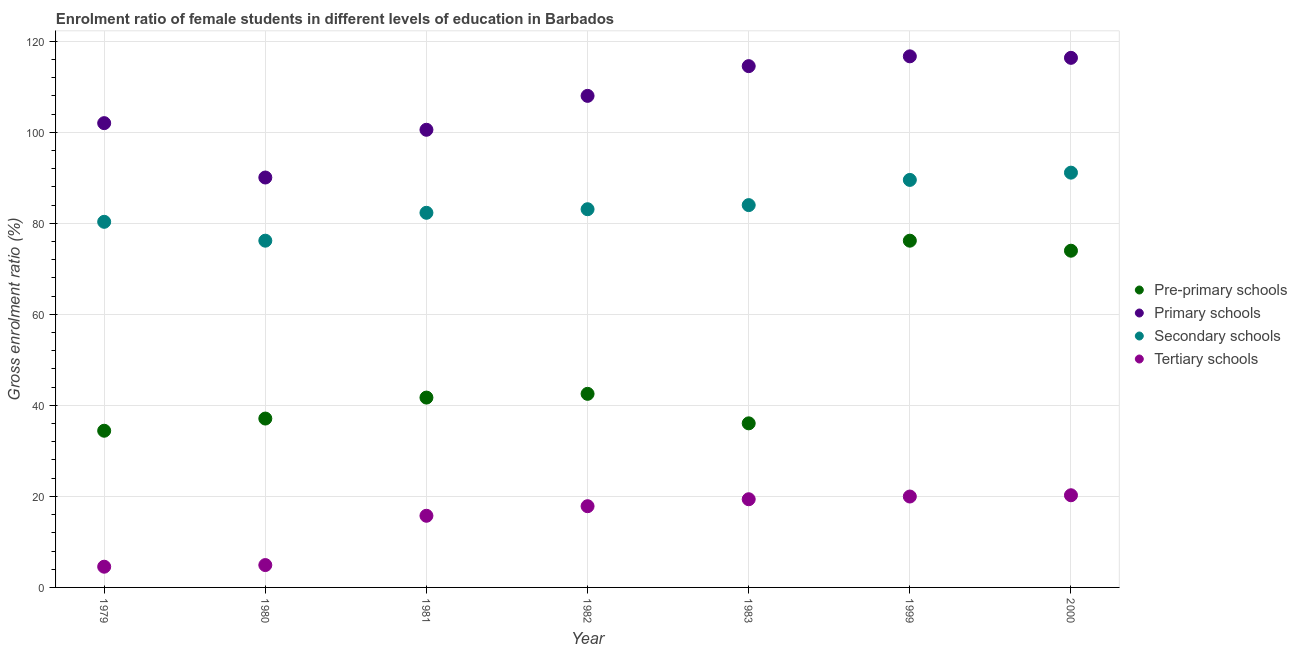How many different coloured dotlines are there?
Your response must be concise. 4. What is the gross enrolment ratio(male) in tertiary schools in 1999?
Give a very brief answer. 19.97. Across all years, what is the maximum gross enrolment ratio(male) in primary schools?
Your answer should be compact. 116.68. Across all years, what is the minimum gross enrolment ratio(male) in pre-primary schools?
Give a very brief answer. 34.42. In which year was the gross enrolment ratio(male) in secondary schools maximum?
Provide a short and direct response. 2000. In which year was the gross enrolment ratio(male) in pre-primary schools minimum?
Your answer should be compact. 1979. What is the total gross enrolment ratio(male) in primary schools in the graph?
Keep it short and to the point. 748.15. What is the difference between the gross enrolment ratio(male) in pre-primary schools in 1980 and that in 1981?
Provide a succinct answer. -4.61. What is the difference between the gross enrolment ratio(male) in secondary schools in 1982 and the gross enrolment ratio(male) in tertiary schools in 1981?
Your answer should be compact. 67.35. What is the average gross enrolment ratio(male) in pre-primary schools per year?
Give a very brief answer. 48.85. In the year 1980, what is the difference between the gross enrolment ratio(male) in pre-primary schools and gross enrolment ratio(male) in secondary schools?
Provide a short and direct response. -39.08. In how many years, is the gross enrolment ratio(male) in tertiary schools greater than 96 %?
Offer a terse response. 0. What is the ratio of the gross enrolment ratio(male) in primary schools in 1979 to that in 1999?
Keep it short and to the point. 0.87. What is the difference between the highest and the second highest gross enrolment ratio(male) in tertiary schools?
Offer a very short reply. 0.28. What is the difference between the highest and the lowest gross enrolment ratio(male) in primary schools?
Your response must be concise. 26.62. In how many years, is the gross enrolment ratio(male) in secondary schools greater than the average gross enrolment ratio(male) in secondary schools taken over all years?
Offer a terse response. 3. Is the sum of the gross enrolment ratio(male) in pre-primary schools in 1981 and 1982 greater than the maximum gross enrolment ratio(male) in tertiary schools across all years?
Make the answer very short. Yes. Is it the case that in every year, the sum of the gross enrolment ratio(male) in pre-primary schools and gross enrolment ratio(male) in primary schools is greater than the gross enrolment ratio(male) in secondary schools?
Keep it short and to the point. Yes. What is the title of the graph?
Give a very brief answer. Enrolment ratio of female students in different levels of education in Barbados. Does "Negligence towards children" appear as one of the legend labels in the graph?
Make the answer very short. No. What is the label or title of the Y-axis?
Provide a short and direct response. Gross enrolment ratio (%). What is the Gross enrolment ratio (%) of Pre-primary schools in 1979?
Offer a very short reply. 34.42. What is the Gross enrolment ratio (%) in Primary schools in 1979?
Provide a succinct answer. 102. What is the Gross enrolment ratio (%) of Secondary schools in 1979?
Provide a short and direct response. 80.32. What is the Gross enrolment ratio (%) in Tertiary schools in 1979?
Keep it short and to the point. 4.55. What is the Gross enrolment ratio (%) of Pre-primary schools in 1980?
Your answer should be compact. 37.1. What is the Gross enrolment ratio (%) in Primary schools in 1980?
Your answer should be very brief. 90.06. What is the Gross enrolment ratio (%) in Secondary schools in 1980?
Keep it short and to the point. 76.18. What is the Gross enrolment ratio (%) of Tertiary schools in 1980?
Your answer should be compact. 4.91. What is the Gross enrolment ratio (%) of Pre-primary schools in 1981?
Make the answer very short. 41.71. What is the Gross enrolment ratio (%) of Primary schools in 1981?
Give a very brief answer. 100.54. What is the Gross enrolment ratio (%) of Secondary schools in 1981?
Your response must be concise. 82.31. What is the Gross enrolment ratio (%) of Tertiary schools in 1981?
Provide a succinct answer. 15.74. What is the Gross enrolment ratio (%) in Pre-primary schools in 1982?
Give a very brief answer. 42.53. What is the Gross enrolment ratio (%) of Primary schools in 1982?
Provide a succinct answer. 107.99. What is the Gross enrolment ratio (%) of Secondary schools in 1982?
Offer a terse response. 83.09. What is the Gross enrolment ratio (%) of Tertiary schools in 1982?
Make the answer very short. 17.85. What is the Gross enrolment ratio (%) of Pre-primary schools in 1983?
Offer a very short reply. 36.05. What is the Gross enrolment ratio (%) of Primary schools in 1983?
Your answer should be compact. 114.53. What is the Gross enrolment ratio (%) of Secondary schools in 1983?
Provide a short and direct response. 84. What is the Gross enrolment ratio (%) in Tertiary schools in 1983?
Provide a short and direct response. 19.37. What is the Gross enrolment ratio (%) of Pre-primary schools in 1999?
Make the answer very short. 76.18. What is the Gross enrolment ratio (%) of Primary schools in 1999?
Your answer should be compact. 116.68. What is the Gross enrolment ratio (%) in Secondary schools in 1999?
Your response must be concise. 89.53. What is the Gross enrolment ratio (%) in Tertiary schools in 1999?
Offer a very short reply. 19.97. What is the Gross enrolment ratio (%) in Pre-primary schools in 2000?
Your answer should be very brief. 73.98. What is the Gross enrolment ratio (%) of Primary schools in 2000?
Your answer should be compact. 116.35. What is the Gross enrolment ratio (%) of Secondary schools in 2000?
Make the answer very short. 91.12. What is the Gross enrolment ratio (%) of Tertiary schools in 2000?
Keep it short and to the point. 20.25. Across all years, what is the maximum Gross enrolment ratio (%) in Pre-primary schools?
Your answer should be very brief. 76.18. Across all years, what is the maximum Gross enrolment ratio (%) of Primary schools?
Your response must be concise. 116.68. Across all years, what is the maximum Gross enrolment ratio (%) of Secondary schools?
Offer a very short reply. 91.12. Across all years, what is the maximum Gross enrolment ratio (%) of Tertiary schools?
Keep it short and to the point. 20.25. Across all years, what is the minimum Gross enrolment ratio (%) in Pre-primary schools?
Your answer should be very brief. 34.42. Across all years, what is the minimum Gross enrolment ratio (%) in Primary schools?
Your answer should be compact. 90.06. Across all years, what is the minimum Gross enrolment ratio (%) in Secondary schools?
Your response must be concise. 76.18. Across all years, what is the minimum Gross enrolment ratio (%) in Tertiary schools?
Keep it short and to the point. 4.55. What is the total Gross enrolment ratio (%) in Pre-primary schools in the graph?
Ensure brevity in your answer.  341.97. What is the total Gross enrolment ratio (%) in Primary schools in the graph?
Make the answer very short. 748.15. What is the total Gross enrolment ratio (%) in Secondary schools in the graph?
Make the answer very short. 586.55. What is the total Gross enrolment ratio (%) in Tertiary schools in the graph?
Ensure brevity in your answer.  102.65. What is the difference between the Gross enrolment ratio (%) of Pre-primary schools in 1979 and that in 1980?
Provide a short and direct response. -2.68. What is the difference between the Gross enrolment ratio (%) of Primary schools in 1979 and that in 1980?
Provide a short and direct response. 11.94. What is the difference between the Gross enrolment ratio (%) of Secondary schools in 1979 and that in 1980?
Your answer should be very brief. 4.15. What is the difference between the Gross enrolment ratio (%) in Tertiary schools in 1979 and that in 1980?
Provide a succinct answer. -0.36. What is the difference between the Gross enrolment ratio (%) of Pre-primary schools in 1979 and that in 1981?
Your answer should be compact. -7.29. What is the difference between the Gross enrolment ratio (%) in Primary schools in 1979 and that in 1981?
Your response must be concise. 1.46. What is the difference between the Gross enrolment ratio (%) of Secondary schools in 1979 and that in 1981?
Provide a short and direct response. -1.98. What is the difference between the Gross enrolment ratio (%) of Tertiary schools in 1979 and that in 1981?
Keep it short and to the point. -11.19. What is the difference between the Gross enrolment ratio (%) of Pre-primary schools in 1979 and that in 1982?
Give a very brief answer. -8.11. What is the difference between the Gross enrolment ratio (%) in Primary schools in 1979 and that in 1982?
Your response must be concise. -5.99. What is the difference between the Gross enrolment ratio (%) of Secondary schools in 1979 and that in 1982?
Make the answer very short. -2.77. What is the difference between the Gross enrolment ratio (%) of Tertiary schools in 1979 and that in 1982?
Offer a terse response. -13.29. What is the difference between the Gross enrolment ratio (%) in Pre-primary schools in 1979 and that in 1983?
Your answer should be compact. -1.63. What is the difference between the Gross enrolment ratio (%) in Primary schools in 1979 and that in 1983?
Your response must be concise. -12.52. What is the difference between the Gross enrolment ratio (%) of Secondary schools in 1979 and that in 1983?
Give a very brief answer. -3.67. What is the difference between the Gross enrolment ratio (%) in Tertiary schools in 1979 and that in 1983?
Your answer should be compact. -14.82. What is the difference between the Gross enrolment ratio (%) in Pre-primary schools in 1979 and that in 1999?
Your response must be concise. -41.75. What is the difference between the Gross enrolment ratio (%) in Primary schools in 1979 and that in 1999?
Give a very brief answer. -14.68. What is the difference between the Gross enrolment ratio (%) of Secondary schools in 1979 and that in 1999?
Your answer should be very brief. -9.21. What is the difference between the Gross enrolment ratio (%) in Tertiary schools in 1979 and that in 1999?
Your response must be concise. -15.42. What is the difference between the Gross enrolment ratio (%) in Pre-primary schools in 1979 and that in 2000?
Keep it short and to the point. -39.55. What is the difference between the Gross enrolment ratio (%) of Primary schools in 1979 and that in 2000?
Offer a terse response. -14.35. What is the difference between the Gross enrolment ratio (%) in Secondary schools in 1979 and that in 2000?
Offer a very short reply. -10.8. What is the difference between the Gross enrolment ratio (%) of Tertiary schools in 1979 and that in 2000?
Your answer should be compact. -15.7. What is the difference between the Gross enrolment ratio (%) in Pre-primary schools in 1980 and that in 1981?
Your response must be concise. -4.61. What is the difference between the Gross enrolment ratio (%) of Primary schools in 1980 and that in 1981?
Provide a short and direct response. -10.49. What is the difference between the Gross enrolment ratio (%) in Secondary schools in 1980 and that in 1981?
Offer a terse response. -6.13. What is the difference between the Gross enrolment ratio (%) of Tertiary schools in 1980 and that in 1981?
Provide a short and direct response. -10.83. What is the difference between the Gross enrolment ratio (%) in Pre-primary schools in 1980 and that in 1982?
Your answer should be compact. -5.43. What is the difference between the Gross enrolment ratio (%) in Primary schools in 1980 and that in 1982?
Offer a very short reply. -17.94. What is the difference between the Gross enrolment ratio (%) in Secondary schools in 1980 and that in 1982?
Your answer should be very brief. -6.91. What is the difference between the Gross enrolment ratio (%) of Tertiary schools in 1980 and that in 1982?
Provide a succinct answer. -12.93. What is the difference between the Gross enrolment ratio (%) in Pre-primary schools in 1980 and that in 1983?
Offer a very short reply. 1.05. What is the difference between the Gross enrolment ratio (%) in Primary schools in 1980 and that in 1983?
Your response must be concise. -24.47. What is the difference between the Gross enrolment ratio (%) in Secondary schools in 1980 and that in 1983?
Give a very brief answer. -7.82. What is the difference between the Gross enrolment ratio (%) in Tertiary schools in 1980 and that in 1983?
Your answer should be compact. -14.46. What is the difference between the Gross enrolment ratio (%) of Pre-primary schools in 1980 and that in 1999?
Make the answer very short. -39.08. What is the difference between the Gross enrolment ratio (%) in Primary schools in 1980 and that in 1999?
Provide a short and direct response. -26.62. What is the difference between the Gross enrolment ratio (%) in Secondary schools in 1980 and that in 1999?
Offer a terse response. -13.35. What is the difference between the Gross enrolment ratio (%) in Tertiary schools in 1980 and that in 1999?
Your answer should be very brief. -15.06. What is the difference between the Gross enrolment ratio (%) in Pre-primary schools in 1980 and that in 2000?
Offer a terse response. -36.87. What is the difference between the Gross enrolment ratio (%) in Primary schools in 1980 and that in 2000?
Offer a very short reply. -26.29. What is the difference between the Gross enrolment ratio (%) of Secondary schools in 1980 and that in 2000?
Offer a very short reply. -14.95. What is the difference between the Gross enrolment ratio (%) in Tertiary schools in 1980 and that in 2000?
Your answer should be very brief. -15.34. What is the difference between the Gross enrolment ratio (%) of Pre-primary schools in 1981 and that in 1982?
Give a very brief answer. -0.82. What is the difference between the Gross enrolment ratio (%) in Primary schools in 1981 and that in 1982?
Your answer should be very brief. -7.45. What is the difference between the Gross enrolment ratio (%) in Secondary schools in 1981 and that in 1982?
Keep it short and to the point. -0.78. What is the difference between the Gross enrolment ratio (%) in Tertiary schools in 1981 and that in 1982?
Give a very brief answer. -2.1. What is the difference between the Gross enrolment ratio (%) in Pre-primary schools in 1981 and that in 1983?
Your response must be concise. 5.66. What is the difference between the Gross enrolment ratio (%) in Primary schools in 1981 and that in 1983?
Offer a terse response. -13.98. What is the difference between the Gross enrolment ratio (%) in Secondary schools in 1981 and that in 1983?
Keep it short and to the point. -1.69. What is the difference between the Gross enrolment ratio (%) in Tertiary schools in 1981 and that in 1983?
Make the answer very short. -3.63. What is the difference between the Gross enrolment ratio (%) in Pre-primary schools in 1981 and that in 1999?
Your response must be concise. -34.47. What is the difference between the Gross enrolment ratio (%) of Primary schools in 1981 and that in 1999?
Offer a terse response. -16.13. What is the difference between the Gross enrolment ratio (%) in Secondary schools in 1981 and that in 1999?
Offer a very short reply. -7.22. What is the difference between the Gross enrolment ratio (%) in Tertiary schools in 1981 and that in 1999?
Make the answer very short. -4.23. What is the difference between the Gross enrolment ratio (%) in Pre-primary schools in 1981 and that in 2000?
Offer a very short reply. -32.27. What is the difference between the Gross enrolment ratio (%) of Primary schools in 1981 and that in 2000?
Keep it short and to the point. -15.81. What is the difference between the Gross enrolment ratio (%) in Secondary schools in 1981 and that in 2000?
Provide a short and direct response. -8.82. What is the difference between the Gross enrolment ratio (%) in Tertiary schools in 1981 and that in 2000?
Give a very brief answer. -4.51. What is the difference between the Gross enrolment ratio (%) of Pre-primary schools in 1982 and that in 1983?
Provide a succinct answer. 6.48. What is the difference between the Gross enrolment ratio (%) in Primary schools in 1982 and that in 1983?
Keep it short and to the point. -6.53. What is the difference between the Gross enrolment ratio (%) in Secondary schools in 1982 and that in 1983?
Offer a terse response. -0.9. What is the difference between the Gross enrolment ratio (%) in Tertiary schools in 1982 and that in 1983?
Make the answer very short. -1.53. What is the difference between the Gross enrolment ratio (%) of Pre-primary schools in 1982 and that in 1999?
Provide a short and direct response. -33.65. What is the difference between the Gross enrolment ratio (%) in Primary schools in 1982 and that in 1999?
Give a very brief answer. -8.68. What is the difference between the Gross enrolment ratio (%) of Secondary schools in 1982 and that in 1999?
Give a very brief answer. -6.44. What is the difference between the Gross enrolment ratio (%) in Tertiary schools in 1982 and that in 1999?
Make the answer very short. -2.13. What is the difference between the Gross enrolment ratio (%) of Pre-primary schools in 1982 and that in 2000?
Your response must be concise. -31.44. What is the difference between the Gross enrolment ratio (%) of Primary schools in 1982 and that in 2000?
Your answer should be very brief. -8.36. What is the difference between the Gross enrolment ratio (%) in Secondary schools in 1982 and that in 2000?
Give a very brief answer. -8.03. What is the difference between the Gross enrolment ratio (%) in Tertiary schools in 1982 and that in 2000?
Your response must be concise. -2.4. What is the difference between the Gross enrolment ratio (%) in Pre-primary schools in 1983 and that in 1999?
Your answer should be very brief. -40.13. What is the difference between the Gross enrolment ratio (%) of Primary schools in 1983 and that in 1999?
Keep it short and to the point. -2.15. What is the difference between the Gross enrolment ratio (%) in Secondary schools in 1983 and that in 1999?
Provide a succinct answer. -5.53. What is the difference between the Gross enrolment ratio (%) in Tertiary schools in 1983 and that in 1999?
Your answer should be very brief. -0.6. What is the difference between the Gross enrolment ratio (%) in Pre-primary schools in 1983 and that in 2000?
Provide a succinct answer. -37.93. What is the difference between the Gross enrolment ratio (%) of Primary schools in 1983 and that in 2000?
Keep it short and to the point. -1.82. What is the difference between the Gross enrolment ratio (%) in Secondary schools in 1983 and that in 2000?
Provide a succinct answer. -7.13. What is the difference between the Gross enrolment ratio (%) in Tertiary schools in 1983 and that in 2000?
Your answer should be very brief. -0.88. What is the difference between the Gross enrolment ratio (%) of Pre-primary schools in 1999 and that in 2000?
Your answer should be very brief. 2.2. What is the difference between the Gross enrolment ratio (%) in Primary schools in 1999 and that in 2000?
Provide a succinct answer. 0.33. What is the difference between the Gross enrolment ratio (%) in Secondary schools in 1999 and that in 2000?
Your response must be concise. -1.59. What is the difference between the Gross enrolment ratio (%) of Tertiary schools in 1999 and that in 2000?
Give a very brief answer. -0.28. What is the difference between the Gross enrolment ratio (%) in Pre-primary schools in 1979 and the Gross enrolment ratio (%) in Primary schools in 1980?
Make the answer very short. -55.64. What is the difference between the Gross enrolment ratio (%) of Pre-primary schools in 1979 and the Gross enrolment ratio (%) of Secondary schools in 1980?
Provide a short and direct response. -41.75. What is the difference between the Gross enrolment ratio (%) in Pre-primary schools in 1979 and the Gross enrolment ratio (%) in Tertiary schools in 1980?
Make the answer very short. 29.51. What is the difference between the Gross enrolment ratio (%) in Primary schools in 1979 and the Gross enrolment ratio (%) in Secondary schools in 1980?
Provide a short and direct response. 25.82. What is the difference between the Gross enrolment ratio (%) of Primary schools in 1979 and the Gross enrolment ratio (%) of Tertiary schools in 1980?
Provide a succinct answer. 97.09. What is the difference between the Gross enrolment ratio (%) of Secondary schools in 1979 and the Gross enrolment ratio (%) of Tertiary schools in 1980?
Provide a short and direct response. 75.41. What is the difference between the Gross enrolment ratio (%) of Pre-primary schools in 1979 and the Gross enrolment ratio (%) of Primary schools in 1981?
Provide a short and direct response. -66.12. What is the difference between the Gross enrolment ratio (%) of Pre-primary schools in 1979 and the Gross enrolment ratio (%) of Secondary schools in 1981?
Your answer should be very brief. -47.88. What is the difference between the Gross enrolment ratio (%) in Pre-primary schools in 1979 and the Gross enrolment ratio (%) in Tertiary schools in 1981?
Provide a short and direct response. 18.68. What is the difference between the Gross enrolment ratio (%) of Primary schools in 1979 and the Gross enrolment ratio (%) of Secondary schools in 1981?
Offer a terse response. 19.69. What is the difference between the Gross enrolment ratio (%) in Primary schools in 1979 and the Gross enrolment ratio (%) in Tertiary schools in 1981?
Your response must be concise. 86.26. What is the difference between the Gross enrolment ratio (%) in Secondary schools in 1979 and the Gross enrolment ratio (%) in Tertiary schools in 1981?
Ensure brevity in your answer.  64.58. What is the difference between the Gross enrolment ratio (%) of Pre-primary schools in 1979 and the Gross enrolment ratio (%) of Primary schools in 1982?
Your response must be concise. -73.57. What is the difference between the Gross enrolment ratio (%) in Pre-primary schools in 1979 and the Gross enrolment ratio (%) in Secondary schools in 1982?
Give a very brief answer. -48.67. What is the difference between the Gross enrolment ratio (%) in Pre-primary schools in 1979 and the Gross enrolment ratio (%) in Tertiary schools in 1982?
Your answer should be very brief. 16.58. What is the difference between the Gross enrolment ratio (%) in Primary schools in 1979 and the Gross enrolment ratio (%) in Secondary schools in 1982?
Keep it short and to the point. 18.91. What is the difference between the Gross enrolment ratio (%) in Primary schools in 1979 and the Gross enrolment ratio (%) in Tertiary schools in 1982?
Keep it short and to the point. 84.16. What is the difference between the Gross enrolment ratio (%) of Secondary schools in 1979 and the Gross enrolment ratio (%) of Tertiary schools in 1982?
Your answer should be very brief. 62.48. What is the difference between the Gross enrolment ratio (%) of Pre-primary schools in 1979 and the Gross enrolment ratio (%) of Primary schools in 1983?
Your answer should be compact. -80.1. What is the difference between the Gross enrolment ratio (%) of Pre-primary schools in 1979 and the Gross enrolment ratio (%) of Secondary schools in 1983?
Offer a very short reply. -49.57. What is the difference between the Gross enrolment ratio (%) of Pre-primary schools in 1979 and the Gross enrolment ratio (%) of Tertiary schools in 1983?
Provide a short and direct response. 15.05. What is the difference between the Gross enrolment ratio (%) of Primary schools in 1979 and the Gross enrolment ratio (%) of Secondary schools in 1983?
Your answer should be very brief. 18.01. What is the difference between the Gross enrolment ratio (%) of Primary schools in 1979 and the Gross enrolment ratio (%) of Tertiary schools in 1983?
Your response must be concise. 82.63. What is the difference between the Gross enrolment ratio (%) of Secondary schools in 1979 and the Gross enrolment ratio (%) of Tertiary schools in 1983?
Provide a short and direct response. 60.95. What is the difference between the Gross enrolment ratio (%) in Pre-primary schools in 1979 and the Gross enrolment ratio (%) in Primary schools in 1999?
Ensure brevity in your answer.  -82.25. What is the difference between the Gross enrolment ratio (%) in Pre-primary schools in 1979 and the Gross enrolment ratio (%) in Secondary schools in 1999?
Your response must be concise. -55.11. What is the difference between the Gross enrolment ratio (%) of Pre-primary schools in 1979 and the Gross enrolment ratio (%) of Tertiary schools in 1999?
Keep it short and to the point. 14.45. What is the difference between the Gross enrolment ratio (%) of Primary schools in 1979 and the Gross enrolment ratio (%) of Secondary schools in 1999?
Offer a terse response. 12.47. What is the difference between the Gross enrolment ratio (%) of Primary schools in 1979 and the Gross enrolment ratio (%) of Tertiary schools in 1999?
Offer a very short reply. 82.03. What is the difference between the Gross enrolment ratio (%) in Secondary schools in 1979 and the Gross enrolment ratio (%) in Tertiary schools in 1999?
Your response must be concise. 60.35. What is the difference between the Gross enrolment ratio (%) of Pre-primary schools in 1979 and the Gross enrolment ratio (%) of Primary schools in 2000?
Offer a terse response. -81.93. What is the difference between the Gross enrolment ratio (%) of Pre-primary schools in 1979 and the Gross enrolment ratio (%) of Secondary schools in 2000?
Give a very brief answer. -56.7. What is the difference between the Gross enrolment ratio (%) in Pre-primary schools in 1979 and the Gross enrolment ratio (%) in Tertiary schools in 2000?
Keep it short and to the point. 14.17. What is the difference between the Gross enrolment ratio (%) of Primary schools in 1979 and the Gross enrolment ratio (%) of Secondary schools in 2000?
Your response must be concise. 10.88. What is the difference between the Gross enrolment ratio (%) in Primary schools in 1979 and the Gross enrolment ratio (%) in Tertiary schools in 2000?
Provide a short and direct response. 81.75. What is the difference between the Gross enrolment ratio (%) of Secondary schools in 1979 and the Gross enrolment ratio (%) of Tertiary schools in 2000?
Keep it short and to the point. 60.07. What is the difference between the Gross enrolment ratio (%) of Pre-primary schools in 1980 and the Gross enrolment ratio (%) of Primary schools in 1981?
Your answer should be very brief. -63.44. What is the difference between the Gross enrolment ratio (%) in Pre-primary schools in 1980 and the Gross enrolment ratio (%) in Secondary schools in 1981?
Ensure brevity in your answer.  -45.21. What is the difference between the Gross enrolment ratio (%) of Pre-primary schools in 1980 and the Gross enrolment ratio (%) of Tertiary schools in 1981?
Offer a very short reply. 21.36. What is the difference between the Gross enrolment ratio (%) in Primary schools in 1980 and the Gross enrolment ratio (%) in Secondary schools in 1981?
Your response must be concise. 7.75. What is the difference between the Gross enrolment ratio (%) of Primary schools in 1980 and the Gross enrolment ratio (%) of Tertiary schools in 1981?
Provide a short and direct response. 74.32. What is the difference between the Gross enrolment ratio (%) of Secondary schools in 1980 and the Gross enrolment ratio (%) of Tertiary schools in 1981?
Offer a terse response. 60.44. What is the difference between the Gross enrolment ratio (%) of Pre-primary schools in 1980 and the Gross enrolment ratio (%) of Primary schools in 1982?
Provide a succinct answer. -70.89. What is the difference between the Gross enrolment ratio (%) of Pre-primary schools in 1980 and the Gross enrolment ratio (%) of Secondary schools in 1982?
Offer a very short reply. -45.99. What is the difference between the Gross enrolment ratio (%) of Pre-primary schools in 1980 and the Gross enrolment ratio (%) of Tertiary schools in 1982?
Give a very brief answer. 19.26. What is the difference between the Gross enrolment ratio (%) in Primary schools in 1980 and the Gross enrolment ratio (%) in Secondary schools in 1982?
Give a very brief answer. 6.97. What is the difference between the Gross enrolment ratio (%) of Primary schools in 1980 and the Gross enrolment ratio (%) of Tertiary schools in 1982?
Keep it short and to the point. 72.21. What is the difference between the Gross enrolment ratio (%) of Secondary schools in 1980 and the Gross enrolment ratio (%) of Tertiary schools in 1982?
Ensure brevity in your answer.  58.33. What is the difference between the Gross enrolment ratio (%) of Pre-primary schools in 1980 and the Gross enrolment ratio (%) of Primary schools in 1983?
Make the answer very short. -77.42. What is the difference between the Gross enrolment ratio (%) in Pre-primary schools in 1980 and the Gross enrolment ratio (%) in Secondary schools in 1983?
Keep it short and to the point. -46.89. What is the difference between the Gross enrolment ratio (%) of Pre-primary schools in 1980 and the Gross enrolment ratio (%) of Tertiary schools in 1983?
Provide a short and direct response. 17.73. What is the difference between the Gross enrolment ratio (%) of Primary schools in 1980 and the Gross enrolment ratio (%) of Secondary schools in 1983?
Keep it short and to the point. 6.06. What is the difference between the Gross enrolment ratio (%) in Primary schools in 1980 and the Gross enrolment ratio (%) in Tertiary schools in 1983?
Keep it short and to the point. 70.68. What is the difference between the Gross enrolment ratio (%) of Secondary schools in 1980 and the Gross enrolment ratio (%) of Tertiary schools in 1983?
Your answer should be very brief. 56.8. What is the difference between the Gross enrolment ratio (%) of Pre-primary schools in 1980 and the Gross enrolment ratio (%) of Primary schools in 1999?
Your answer should be compact. -79.58. What is the difference between the Gross enrolment ratio (%) in Pre-primary schools in 1980 and the Gross enrolment ratio (%) in Secondary schools in 1999?
Provide a succinct answer. -52.43. What is the difference between the Gross enrolment ratio (%) of Pre-primary schools in 1980 and the Gross enrolment ratio (%) of Tertiary schools in 1999?
Your response must be concise. 17.13. What is the difference between the Gross enrolment ratio (%) of Primary schools in 1980 and the Gross enrolment ratio (%) of Secondary schools in 1999?
Your answer should be very brief. 0.53. What is the difference between the Gross enrolment ratio (%) of Primary schools in 1980 and the Gross enrolment ratio (%) of Tertiary schools in 1999?
Ensure brevity in your answer.  70.09. What is the difference between the Gross enrolment ratio (%) of Secondary schools in 1980 and the Gross enrolment ratio (%) of Tertiary schools in 1999?
Your answer should be compact. 56.21. What is the difference between the Gross enrolment ratio (%) in Pre-primary schools in 1980 and the Gross enrolment ratio (%) in Primary schools in 2000?
Ensure brevity in your answer.  -79.25. What is the difference between the Gross enrolment ratio (%) of Pre-primary schools in 1980 and the Gross enrolment ratio (%) of Secondary schools in 2000?
Provide a short and direct response. -54.02. What is the difference between the Gross enrolment ratio (%) in Pre-primary schools in 1980 and the Gross enrolment ratio (%) in Tertiary schools in 2000?
Keep it short and to the point. 16.85. What is the difference between the Gross enrolment ratio (%) of Primary schools in 1980 and the Gross enrolment ratio (%) of Secondary schools in 2000?
Offer a very short reply. -1.07. What is the difference between the Gross enrolment ratio (%) in Primary schools in 1980 and the Gross enrolment ratio (%) in Tertiary schools in 2000?
Your answer should be compact. 69.81. What is the difference between the Gross enrolment ratio (%) of Secondary schools in 1980 and the Gross enrolment ratio (%) of Tertiary schools in 2000?
Keep it short and to the point. 55.93. What is the difference between the Gross enrolment ratio (%) of Pre-primary schools in 1981 and the Gross enrolment ratio (%) of Primary schools in 1982?
Give a very brief answer. -66.29. What is the difference between the Gross enrolment ratio (%) of Pre-primary schools in 1981 and the Gross enrolment ratio (%) of Secondary schools in 1982?
Provide a succinct answer. -41.38. What is the difference between the Gross enrolment ratio (%) of Pre-primary schools in 1981 and the Gross enrolment ratio (%) of Tertiary schools in 1982?
Provide a succinct answer. 23.86. What is the difference between the Gross enrolment ratio (%) in Primary schools in 1981 and the Gross enrolment ratio (%) in Secondary schools in 1982?
Provide a succinct answer. 17.45. What is the difference between the Gross enrolment ratio (%) in Primary schools in 1981 and the Gross enrolment ratio (%) in Tertiary schools in 1982?
Offer a terse response. 82.7. What is the difference between the Gross enrolment ratio (%) in Secondary schools in 1981 and the Gross enrolment ratio (%) in Tertiary schools in 1982?
Make the answer very short. 64.46. What is the difference between the Gross enrolment ratio (%) in Pre-primary schools in 1981 and the Gross enrolment ratio (%) in Primary schools in 1983?
Make the answer very short. -72.82. What is the difference between the Gross enrolment ratio (%) in Pre-primary schools in 1981 and the Gross enrolment ratio (%) in Secondary schools in 1983?
Your response must be concise. -42.29. What is the difference between the Gross enrolment ratio (%) of Pre-primary schools in 1981 and the Gross enrolment ratio (%) of Tertiary schools in 1983?
Offer a very short reply. 22.33. What is the difference between the Gross enrolment ratio (%) of Primary schools in 1981 and the Gross enrolment ratio (%) of Secondary schools in 1983?
Make the answer very short. 16.55. What is the difference between the Gross enrolment ratio (%) of Primary schools in 1981 and the Gross enrolment ratio (%) of Tertiary schools in 1983?
Offer a very short reply. 81.17. What is the difference between the Gross enrolment ratio (%) of Secondary schools in 1981 and the Gross enrolment ratio (%) of Tertiary schools in 1983?
Make the answer very short. 62.93. What is the difference between the Gross enrolment ratio (%) in Pre-primary schools in 1981 and the Gross enrolment ratio (%) in Primary schools in 1999?
Your response must be concise. -74.97. What is the difference between the Gross enrolment ratio (%) in Pre-primary schools in 1981 and the Gross enrolment ratio (%) in Secondary schools in 1999?
Offer a very short reply. -47.82. What is the difference between the Gross enrolment ratio (%) of Pre-primary schools in 1981 and the Gross enrolment ratio (%) of Tertiary schools in 1999?
Keep it short and to the point. 21.74. What is the difference between the Gross enrolment ratio (%) of Primary schools in 1981 and the Gross enrolment ratio (%) of Secondary schools in 1999?
Offer a terse response. 11.01. What is the difference between the Gross enrolment ratio (%) in Primary schools in 1981 and the Gross enrolment ratio (%) in Tertiary schools in 1999?
Your response must be concise. 80.57. What is the difference between the Gross enrolment ratio (%) in Secondary schools in 1981 and the Gross enrolment ratio (%) in Tertiary schools in 1999?
Keep it short and to the point. 62.34. What is the difference between the Gross enrolment ratio (%) in Pre-primary schools in 1981 and the Gross enrolment ratio (%) in Primary schools in 2000?
Give a very brief answer. -74.64. What is the difference between the Gross enrolment ratio (%) of Pre-primary schools in 1981 and the Gross enrolment ratio (%) of Secondary schools in 2000?
Your answer should be very brief. -49.42. What is the difference between the Gross enrolment ratio (%) in Pre-primary schools in 1981 and the Gross enrolment ratio (%) in Tertiary schools in 2000?
Keep it short and to the point. 21.46. What is the difference between the Gross enrolment ratio (%) of Primary schools in 1981 and the Gross enrolment ratio (%) of Secondary schools in 2000?
Your answer should be compact. 9.42. What is the difference between the Gross enrolment ratio (%) in Primary schools in 1981 and the Gross enrolment ratio (%) in Tertiary schools in 2000?
Provide a succinct answer. 80.29. What is the difference between the Gross enrolment ratio (%) in Secondary schools in 1981 and the Gross enrolment ratio (%) in Tertiary schools in 2000?
Offer a terse response. 62.06. What is the difference between the Gross enrolment ratio (%) in Pre-primary schools in 1982 and the Gross enrolment ratio (%) in Primary schools in 1983?
Provide a short and direct response. -72. What is the difference between the Gross enrolment ratio (%) of Pre-primary schools in 1982 and the Gross enrolment ratio (%) of Secondary schools in 1983?
Keep it short and to the point. -41.46. What is the difference between the Gross enrolment ratio (%) in Pre-primary schools in 1982 and the Gross enrolment ratio (%) in Tertiary schools in 1983?
Your answer should be very brief. 23.16. What is the difference between the Gross enrolment ratio (%) of Primary schools in 1982 and the Gross enrolment ratio (%) of Secondary schools in 1983?
Your response must be concise. 24. What is the difference between the Gross enrolment ratio (%) in Primary schools in 1982 and the Gross enrolment ratio (%) in Tertiary schools in 1983?
Your answer should be very brief. 88.62. What is the difference between the Gross enrolment ratio (%) of Secondary schools in 1982 and the Gross enrolment ratio (%) of Tertiary schools in 1983?
Offer a terse response. 63.72. What is the difference between the Gross enrolment ratio (%) in Pre-primary schools in 1982 and the Gross enrolment ratio (%) in Primary schools in 1999?
Your answer should be compact. -74.15. What is the difference between the Gross enrolment ratio (%) of Pre-primary schools in 1982 and the Gross enrolment ratio (%) of Secondary schools in 1999?
Provide a succinct answer. -47. What is the difference between the Gross enrolment ratio (%) of Pre-primary schools in 1982 and the Gross enrolment ratio (%) of Tertiary schools in 1999?
Provide a short and direct response. 22.56. What is the difference between the Gross enrolment ratio (%) in Primary schools in 1982 and the Gross enrolment ratio (%) in Secondary schools in 1999?
Your response must be concise. 18.46. What is the difference between the Gross enrolment ratio (%) in Primary schools in 1982 and the Gross enrolment ratio (%) in Tertiary schools in 1999?
Your answer should be very brief. 88.02. What is the difference between the Gross enrolment ratio (%) of Secondary schools in 1982 and the Gross enrolment ratio (%) of Tertiary schools in 1999?
Your response must be concise. 63.12. What is the difference between the Gross enrolment ratio (%) of Pre-primary schools in 1982 and the Gross enrolment ratio (%) of Primary schools in 2000?
Keep it short and to the point. -73.82. What is the difference between the Gross enrolment ratio (%) of Pre-primary schools in 1982 and the Gross enrolment ratio (%) of Secondary schools in 2000?
Provide a succinct answer. -48.59. What is the difference between the Gross enrolment ratio (%) of Pre-primary schools in 1982 and the Gross enrolment ratio (%) of Tertiary schools in 2000?
Ensure brevity in your answer.  22.28. What is the difference between the Gross enrolment ratio (%) in Primary schools in 1982 and the Gross enrolment ratio (%) in Secondary schools in 2000?
Provide a short and direct response. 16.87. What is the difference between the Gross enrolment ratio (%) of Primary schools in 1982 and the Gross enrolment ratio (%) of Tertiary schools in 2000?
Give a very brief answer. 87.74. What is the difference between the Gross enrolment ratio (%) in Secondary schools in 1982 and the Gross enrolment ratio (%) in Tertiary schools in 2000?
Keep it short and to the point. 62.84. What is the difference between the Gross enrolment ratio (%) of Pre-primary schools in 1983 and the Gross enrolment ratio (%) of Primary schools in 1999?
Your answer should be compact. -80.63. What is the difference between the Gross enrolment ratio (%) in Pre-primary schools in 1983 and the Gross enrolment ratio (%) in Secondary schools in 1999?
Ensure brevity in your answer.  -53.48. What is the difference between the Gross enrolment ratio (%) in Pre-primary schools in 1983 and the Gross enrolment ratio (%) in Tertiary schools in 1999?
Make the answer very short. 16.08. What is the difference between the Gross enrolment ratio (%) in Primary schools in 1983 and the Gross enrolment ratio (%) in Secondary schools in 1999?
Make the answer very short. 25. What is the difference between the Gross enrolment ratio (%) of Primary schools in 1983 and the Gross enrolment ratio (%) of Tertiary schools in 1999?
Ensure brevity in your answer.  94.55. What is the difference between the Gross enrolment ratio (%) in Secondary schools in 1983 and the Gross enrolment ratio (%) in Tertiary schools in 1999?
Make the answer very short. 64.02. What is the difference between the Gross enrolment ratio (%) in Pre-primary schools in 1983 and the Gross enrolment ratio (%) in Primary schools in 2000?
Ensure brevity in your answer.  -80.3. What is the difference between the Gross enrolment ratio (%) of Pre-primary schools in 1983 and the Gross enrolment ratio (%) of Secondary schools in 2000?
Make the answer very short. -55.08. What is the difference between the Gross enrolment ratio (%) in Pre-primary schools in 1983 and the Gross enrolment ratio (%) in Tertiary schools in 2000?
Your response must be concise. 15.8. What is the difference between the Gross enrolment ratio (%) of Primary schools in 1983 and the Gross enrolment ratio (%) of Secondary schools in 2000?
Your answer should be compact. 23.4. What is the difference between the Gross enrolment ratio (%) of Primary schools in 1983 and the Gross enrolment ratio (%) of Tertiary schools in 2000?
Provide a succinct answer. 94.28. What is the difference between the Gross enrolment ratio (%) of Secondary schools in 1983 and the Gross enrolment ratio (%) of Tertiary schools in 2000?
Keep it short and to the point. 63.75. What is the difference between the Gross enrolment ratio (%) in Pre-primary schools in 1999 and the Gross enrolment ratio (%) in Primary schools in 2000?
Keep it short and to the point. -40.17. What is the difference between the Gross enrolment ratio (%) of Pre-primary schools in 1999 and the Gross enrolment ratio (%) of Secondary schools in 2000?
Your answer should be compact. -14.95. What is the difference between the Gross enrolment ratio (%) in Pre-primary schools in 1999 and the Gross enrolment ratio (%) in Tertiary schools in 2000?
Ensure brevity in your answer.  55.93. What is the difference between the Gross enrolment ratio (%) of Primary schools in 1999 and the Gross enrolment ratio (%) of Secondary schools in 2000?
Provide a succinct answer. 25.55. What is the difference between the Gross enrolment ratio (%) of Primary schools in 1999 and the Gross enrolment ratio (%) of Tertiary schools in 2000?
Your response must be concise. 96.43. What is the difference between the Gross enrolment ratio (%) of Secondary schools in 1999 and the Gross enrolment ratio (%) of Tertiary schools in 2000?
Your answer should be compact. 69.28. What is the average Gross enrolment ratio (%) in Pre-primary schools per year?
Ensure brevity in your answer.  48.85. What is the average Gross enrolment ratio (%) in Primary schools per year?
Give a very brief answer. 106.88. What is the average Gross enrolment ratio (%) in Secondary schools per year?
Provide a short and direct response. 83.79. What is the average Gross enrolment ratio (%) of Tertiary schools per year?
Give a very brief answer. 14.66. In the year 1979, what is the difference between the Gross enrolment ratio (%) in Pre-primary schools and Gross enrolment ratio (%) in Primary schools?
Your answer should be very brief. -67.58. In the year 1979, what is the difference between the Gross enrolment ratio (%) in Pre-primary schools and Gross enrolment ratio (%) in Secondary schools?
Ensure brevity in your answer.  -45.9. In the year 1979, what is the difference between the Gross enrolment ratio (%) in Pre-primary schools and Gross enrolment ratio (%) in Tertiary schools?
Offer a very short reply. 29.87. In the year 1979, what is the difference between the Gross enrolment ratio (%) of Primary schools and Gross enrolment ratio (%) of Secondary schools?
Give a very brief answer. 21.68. In the year 1979, what is the difference between the Gross enrolment ratio (%) in Primary schools and Gross enrolment ratio (%) in Tertiary schools?
Provide a succinct answer. 97.45. In the year 1979, what is the difference between the Gross enrolment ratio (%) in Secondary schools and Gross enrolment ratio (%) in Tertiary schools?
Offer a terse response. 75.77. In the year 1980, what is the difference between the Gross enrolment ratio (%) in Pre-primary schools and Gross enrolment ratio (%) in Primary schools?
Your response must be concise. -52.96. In the year 1980, what is the difference between the Gross enrolment ratio (%) of Pre-primary schools and Gross enrolment ratio (%) of Secondary schools?
Make the answer very short. -39.08. In the year 1980, what is the difference between the Gross enrolment ratio (%) of Pre-primary schools and Gross enrolment ratio (%) of Tertiary schools?
Give a very brief answer. 32.19. In the year 1980, what is the difference between the Gross enrolment ratio (%) in Primary schools and Gross enrolment ratio (%) in Secondary schools?
Ensure brevity in your answer.  13.88. In the year 1980, what is the difference between the Gross enrolment ratio (%) of Primary schools and Gross enrolment ratio (%) of Tertiary schools?
Offer a very short reply. 85.15. In the year 1980, what is the difference between the Gross enrolment ratio (%) in Secondary schools and Gross enrolment ratio (%) in Tertiary schools?
Provide a succinct answer. 71.27. In the year 1981, what is the difference between the Gross enrolment ratio (%) of Pre-primary schools and Gross enrolment ratio (%) of Primary schools?
Provide a succinct answer. -58.84. In the year 1981, what is the difference between the Gross enrolment ratio (%) of Pre-primary schools and Gross enrolment ratio (%) of Secondary schools?
Ensure brevity in your answer.  -40.6. In the year 1981, what is the difference between the Gross enrolment ratio (%) in Pre-primary schools and Gross enrolment ratio (%) in Tertiary schools?
Give a very brief answer. 25.97. In the year 1981, what is the difference between the Gross enrolment ratio (%) in Primary schools and Gross enrolment ratio (%) in Secondary schools?
Provide a succinct answer. 18.24. In the year 1981, what is the difference between the Gross enrolment ratio (%) of Primary schools and Gross enrolment ratio (%) of Tertiary schools?
Keep it short and to the point. 84.8. In the year 1981, what is the difference between the Gross enrolment ratio (%) of Secondary schools and Gross enrolment ratio (%) of Tertiary schools?
Your answer should be very brief. 66.57. In the year 1982, what is the difference between the Gross enrolment ratio (%) in Pre-primary schools and Gross enrolment ratio (%) in Primary schools?
Provide a succinct answer. -65.46. In the year 1982, what is the difference between the Gross enrolment ratio (%) in Pre-primary schools and Gross enrolment ratio (%) in Secondary schools?
Provide a succinct answer. -40.56. In the year 1982, what is the difference between the Gross enrolment ratio (%) in Pre-primary schools and Gross enrolment ratio (%) in Tertiary schools?
Offer a terse response. 24.68. In the year 1982, what is the difference between the Gross enrolment ratio (%) in Primary schools and Gross enrolment ratio (%) in Secondary schools?
Offer a very short reply. 24.9. In the year 1982, what is the difference between the Gross enrolment ratio (%) in Primary schools and Gross enrolment ratio (%) in Tertiary schools?
Offer a very short reply. 90.15. In the year 1982, what is the difference between the Gross enrolment ratio (%) in Secondary schools and Gross enrolment ratio (%) in Tertiary schools?
Give a very brief answer. 65.25. In the year 1983, what is the difference between the Gross enrolment ratio (%) in Pre-primary schools and Gross enrolment ratio (%) in Primary schools?
Your response must be concise. -78.48. In the year 1983, what is the difference between the Gross enrolment ratio (%) of Pre-primary schools and Gross enrolment ratio (%) of Secondary schools?
Your response must be concise. -47.95. In the year 1983, what is the difference between the Gross enrolment ratio (%) in Pre-primary schools and Gross enrolment ratio (%) in Tertiary schools?
Provide a short and direct response. 16.68. In the year 1983, what is the difference between the Gross enrolment ratio (%) of Primary schools and Gross enrolment ratio (%) of Secondary schools?
Give a very brief answer. 30.53. In the year 1983, what is the difference between the Gross enrolment ratio (%) of Primary schools and Gross enrolment ratio (%) of Tertiary schools?
Make the answer very short. 95.15. In the year 1983, what is the difference between the Gross enrolment ratio (%) of Secondary schools and Gross enrolment ratio (%) of Tertiary schools?
Ensure brevity in your answer.  64.62. In the year 1999, what is the difference between the Gross enrolment ratio (%) of Pre-primary schools and Gross enrolment ratio (%) of Primary schools?
Make the answer very short. -40.5. In the year 1999, what is the difference between the Gross enrolment ratio (%) in Pre-primary schools and Gross enrolment ratio (%) in Secondary schools?
Your answer should be compact. -13.35. In the year 1999, what is the difference between the Gross enrolment ratio (%) in Pre-primary schools and Gross enrolment ratio (%) in Tertiary schools?
Your answer should be compact. 56.21. In the year 1999, what is the difference between the Gross enrolment ratio (%) of Primary schools and Gross enrolment ratio (%) of Secondary schools?
Offer a terse response. 27.15. In the year 1999, what is the difference between the Gross enrolment ratio (%) of Primary schools and Gross enrolment ratio (%) of Tertiary schools?
Your answer should be compact. 96.71. In the year 1999, what is the difference between the Gross enrolment ratio (%) of Secondary schools and Gross enrolment ratio (%) of Tertiary schools?
Keep it short and to the point. 69.56. In the year 2000, what is the difference between the Gross enrolment ratio (%) of Pre-primary schools and Gross enrolment ratio (%) of Primary schools?
Offer a terse response. -42.37. In the year 2000, what is the difference between the Gross enrolment ratio (%) of Pre-primary schools and Gross enrolment ratio (%) of Secondary schools?
Keep it short and to the point. -17.15. In the year 2000, what is the difference between the Gross enrolment ratio (%) in Pre-primary schools and Gross enrolment ratio (%) in Tertiary schools?
Keep it short and to the point. 53.73. In the year 2000, what is the difference between the Gross enrolment ratio (%) in Primary schools and Gross enrolment ratio (%) in Secondary schools?
Keep it short and to the point. 25.23. In the year 2000, what is the difference between the Gross enrolment ratio (%) of Primary schools and Gross enrolment ratio (%) of Tertiary schools?
Provide a succinct answer. 96.1. In the year 2000, what is the difference between the Gross enrolment ratio (%) of Secondary schools and Gross enrolment ratio (%) of Tertiary schools?
Your answer should be very brief. 70.88. What is the ratio of the Gross enrolment ratio (%) in Pre-primary schools in 1979 to that in 1980?
Provide a succinct answer. 0.93. What is the ratio of the Gross enrolment ratio (%) in Primary schools in 1979 to that in 1980?
Provide a short and direct response. 1.13. What is the ratio of the Gross enrolment ratio (%) in Secondary schools in 1979 to that in 1980?
Provide a short and direct response. 1.05. What is the ratio of the Gross enrolment ratio (%) of Tertiary schools in 1979 to that in 1980?
Ensure brevity in your answer.  0.93. What is the ratio of the Gross enrolment ratio (%) in Pre-primary schools in 1979 to that in 1981?
Keep it short and to the point. 0.83. What is the ratio of the Gross enrolment ratio (%) of Primary schools in 1979 to that in 1981?
Provide a short and direct response. 1.01. What is the ratio of the Gross enrolment ratio (%) in Secondary schools in 1979 to that in 1981?
Your answer should be compact. 0.98. What is the ratio of the Gross enrolment ratio (%) of Tertiary schools in 1979 to that in 1981?
Offer a terse response. 0.29. What is the ratio of the Gross enrolment ratio (%) of Pre-primary schools in 1979 to that in 1982?
Your response must be concise. 0.81. What is the ratio of the Gross enrolment ratio (%) of Primary schools in 1979 to that in 1982?
Your answer should be compact. 0.94. What is the ratio of the Gross enrolment ratio (%) in Secondary schools in 1979 to that in 1982?
Provide a short and direct response. 0.97. What is the ratio of the Gross enrolment ratio (%) in Tertiary schools in 1979 to that in 1982?
Your answer should be compact. 0.26. What is the ratio of the Gross enrolment ratio (%) of Pre-primary schools in 1979 to that in 1983?
Offer a very short reply. 0.95. What is the ratio of the Gross enrolment ratio (%) of Primary schools in 1979 to that in 1983?
Your answer should be very brief. 0.89. What is the ratio of the Gross enrolment ratio (%) in Secondary schools in 1979 to that in 1983?
Your response must be concise. 0.96. What is the ratio of the Gross enrolment ratio (%) of Tertiary schools in 1979 to that in 1983?
Your answer should be compact. 0.23. What is the ratio of the Gross enrolment ratio (%) of Pre-primary schools in 1979 to that in 1999?
Your answer should be very brief. 0.45. What is the ratio of the Gross enrolment ratio (%) in Primary schools in 1979 to that in 1999?
Provide a succinct answer. 0.87. What is the ratio of the Gross enrolment ratio (%) of Secondary schools in 1979 to that in 1999?
Your response must be concise. 0.9. What is the ratio of the Gross enrolment ratio (%) in Tertiary schools in 1979 to that in 1999?
Keep it short and to the point. 0.23. What is the ratio of the Gross enrolment ratio (%) in Pre-primary schools in 1979 to that in 2000?
Your answer should be very brief. 0.47. What is the ratio of the Gross enrolment ratio (%) in Primary schools in 1979 to that in 2000?
Your answer should be compact. 0.88. What is the ratio of the Gross enrolment ratio (%) of Secondary schools in 1979 to that in 2000?
Keep it short and to the point. 0.88. What is the ratio of the Gross enrolment ratio (%) of Tertiary schools in 1979 to that in 2000?
Make the answer very short. 0.22. What is the ratio of the Gross enrolment ratio (%) of Pre-primary schools in 1980 to that in 1981?
Offer a very short reply. 0.89. What is the ratio of the Gross enrolment ratio (%) in Primary schools in 1980 to that in 1981?
Offer a very short reply. 0.9. What is the ratio of the Gross enrolment ratio (%) of Secondary schools in 1980 to that in 1981?
Provide a succinct answer. 0.93. What is the ratio of the Gross enrolment ratio (%) of Tertiary schools in 1980 to that in 1981?
Keep it short and to the point. 0.31. What is the ratio of the Gross enrolment ratio (%) of Pre-primary schools in 1980 to that in 1982?
Ensure brevity in your answer.  0.87. What is the ratio of the Gross enrolment ratio (%) in Primary schools in 1980 to that in 1982?
Your answer should be compact. 0.83. What is the ratio of the Gross enrolment ratio (%) of Secondary schools in 1980 to that in 1982?
Offer a terse response. 0.92. What is the ratio of the Gross enrolment ratio (%) in Tertiary schools in 1980 to that in 1982?
Make the answer very short. 0.28. What is the ratio of the Gross enrolment ratio (%) of Pre-primary schools in 1980 to that in 1983?
Provide a short and direct response. 1.03. What is the ratio of the Gross enrolment ratio (%) of Primary schools in 1980 to that in 1983?
Ensure brevity in your answer.  0.79. What is the ratio of the Gross enrolment ratio (%) in Secondary schools in 1980 to that in 1983?
Keep it short and to the point. 0.91. What is the ratio of the Gross enrolment ratio (%) in Tertiary schools in 1980 to that in 1983?
Offer a terse response. 0.25. What is the ratio of the Gross enrolment ratio (%) of Pre-primary schools in 1980 to that in 1999?
Give a very brief answer. 0.49. What is the ratio of the Gross enrolment ratio (%) of Primary schools in 1980 to that in 1999?
Your answer should be very brief. 0.77. What is the ratio of the Gross enrolment ratio (%) in Secondary schools in 1980 to that in 1999?
Your answer should be compact. 0.85. What is the ratio of the Gross enrolment ratio (%) in Tertiary schools in 1980 to that in 1999?
Offer a terse response. 0.25. What is the ratio of the Gross enrolment ratio (%) of Pre-primary schools in 1980 to that in 2000?
Make the answer very short. 0.5. What is the ratio of the Gross enrolment ratio (%) in Primary schools in 1980 to that in 2000?
Your answer should be very brief. 0.77. What is the ratio of the Gross enrolment ratio (%) in Secondary schools in 1980 to that in 2000?
Give a very brief answer. 0.84. What is the ratio of the Gross enrolment ratio (%) of Tertiary schools in 1980 to that in 2000?
Give a very brief answer. 0.24. What is the ratio of the Gross enrolment ratio (%) in Pre-primary schools in 1981 to that in 1982?
Provide a succinct answer. 0.98. What is the ratio of the Gross enrolment ratio (%) of Primary schools in 1981 to that in 1982?
Your answer should be compact. 0.93. What is the ratio of the Gross enrolment ratio (%) in Secondary schools in 1981 to that in 1982?
Offer a terse response. 0.99. What is the ratio of the Gross enrolment ratio (%) in Tertiary schools in 1981 to that in 1982?
Your answer should be very brief. 0.88. What is the ratio of the Gross enrolment ratio (%) of Pre-primary schools in 1981 to that in 1983?
Your answer should be very brief. 1.16. What is the ratio of the Gross enrolment ratio (%) of Primary schools in 1981 to that in 1983?
Your answer should be very brief. 0.88. What is the ratio of the Gross enrolment ratio (%) of Secondary schools in 1981 to that in 1983?
Make the answer very short. 0.98. What is the ratio of the Gross enrolment ratio (%) in Tertiary schools in 1981 to that in 1983?
Your response must be concise. 0.81. What is the ratio of the Gross enrolment ratio (%) of Pre-primary schools in 1981 to that in 1999?
Keep it short and to the point. 0.55. What is the ratio of the Gross enrolment ratio (%) in Primary schools in 1981 to that in 1999?
Make the answer very short. 0.86. What is the ratio of the Gross enrolment ratio (%) of Secondary schools in 1981 to that in 1999?
Ensure brevity in your answer.  0.92. What is the ratio of the Gross enrolment ratio (%) of Tertiary schools in 1981 to that in 1999?
Offer a very short reply. 0.79. What is the ratio of the Gross enrolment ratio (%) in Pre-primary schools in 1981 to that in 2000?
Your answer should be compact. 0.56. What is the ratio of the Gross enrolment ratio (%) in Primary schools in 1981 to that in 2000?
Ensure brevity in your answer.  0.86. What is the ratio of the Gross enrolment ratio (%) in Secondary schools in 1981 to that in 2000?
Your response must be concise. 0.9. What is the ratio of the Gross enrolment ratio (%) in Tertiary schools in 1981 to that in 2000?
Ensure brevity in your answer.  0.78. What is the ratio of the Gross enrolment ratio (%) in Pre-primary schools in 1982 to that in 1983?
Make the answer very short. 1.18. What is the ratio of the Gross enrolment ratio (%) of Primary schools in 1982 to that in 1983?
Ensure brevity in your answer.  0.94. What is the ratio of the Gross enrolment ratio (%) in Tertiary schools in 1982 to that in 1983?
Give a very brief answer. 0.92. What is the ratio of the Gross enrolment ratio (%) in Pre-primary schools in 1982 to that in 1999?
Offer a very short reply. 0.56. What is the ratio of the Gross enrolment ratio (%) in Primary schools in 1982 to that in 1999?
Your response must be concise. 0.93. What is the ratio of the Gross enrolment ratio (%) in Secondary schools in 1982 to that in 1999?
Provide a short and direct response. 0.93. What is the ratio of the Gross enrolment ratio (%) in Tertiary schools in 1982 to that in 1999?
Make the answer very short. 0.89. What is the ratio of the Gross enrolment ratio (%) of Pre-primary schools in 1982 to that in 2000?
Offer a very short reply. 0.57. What is the ratio of the Gross enrolment ratio (%) in Primary schools in 1982 to that in 2000?
Make the answer very short. 0.93. What is the ratio of the Gross enrolment ratio (%) of Secondary schools in 1982 to that in 2000?
Offer a very short reply. 0.91. What is the ratio of the Gross enrolment ratio (%) in Tertiary schools in 1982 to that in 2000?
Your response must be concise. 0.88. What is the ratio of the Gross enrolment ratio (%) of Pre-primary schools in 1983 to that in 1999?
Keep it short and to the point. 0.47. What is the ratio of the Gross enrolment ratio (%) in Primary schools in 1983 to that in 1999?
Your answer should be compact. 0.98. What is the ratio of the Gross enrolment ratio (%) in Secondary schools in 1983 to that in 1999?
Make the answer very short. 0.94. What is the ratio of the Gross enrolment ratio (%) in Tertiary schools in 1983 to that in 1999?
Offer a terse response. 0.97. What is the ratio of the Gross enrolment ratio (%) of Pre-primary schools in 1983 to that in 2000?
Offer a terse response. 0.49. What is the ratio of the Gross enrolment ratio (%) of Primary schools in 1983 to that in 2000?
Ensure brevity in your answer.  0.98. What is the ratio of the Gross enrolment ratio (%) in Secondary schools in 1983 to that in 2000?
Ensure brevity in your answer.  0.92. What is the ratio of the Gross enrolment ratio (%) of Tertiary schools in 1983 to that in 2000?
Your answer should be compact. 0.96. What is the ratio of the Gross enrolment ratio (%) of Pre-primary schools in 1999 to that in 2000?
Keep it short and to the point. 1.03. What is the ratio of the Gross enrolment ratio (%) in Secondary schools in 1999 to that in 2000?
Provide a succinct answer. 0.98. What is the ratio of the Gross enrolment ratio (%) of Tertiary schools in 1999 to that in 2000?
Your response must be concise. 0.99. What is the difference between the highest and the second highest Gross enrolment ratio (%) of Pre-primary schools?
Make the answer very short. 2.2. What is the difference between the highest and the second highest Gross enrolment ratio (%) in Primary schools?
Keep it short and to the point. 0.33. What is the difference between the highest and the second highest Gross enrolment ratio (%) of Secondary schools?
Provide a succinct answer. 1.59. What is the difference between the highest and the second highest Gross enrolment ratio (%) in Tertiary schools?
Provide a succinct answer. 0.28. What is the difference between the highest and the lowest Gross enrolment ratio (%) in Pre-primary schools?
Give a very brief answer. 41.75. What is the difference between the highest and the lowest Gross enrolment ratio (%) in Primary schools?
Offer a terse response. 26.62. What is the difference between the highest and the lowest Gross enrolment ratio (%) of Secondary schools?
Provide a short and direct response. 14.95. What is the difference between the highest and the lowest Gross enrolment ratio (%) of Tertiary schools?
Your response must be concise. 15.7. 